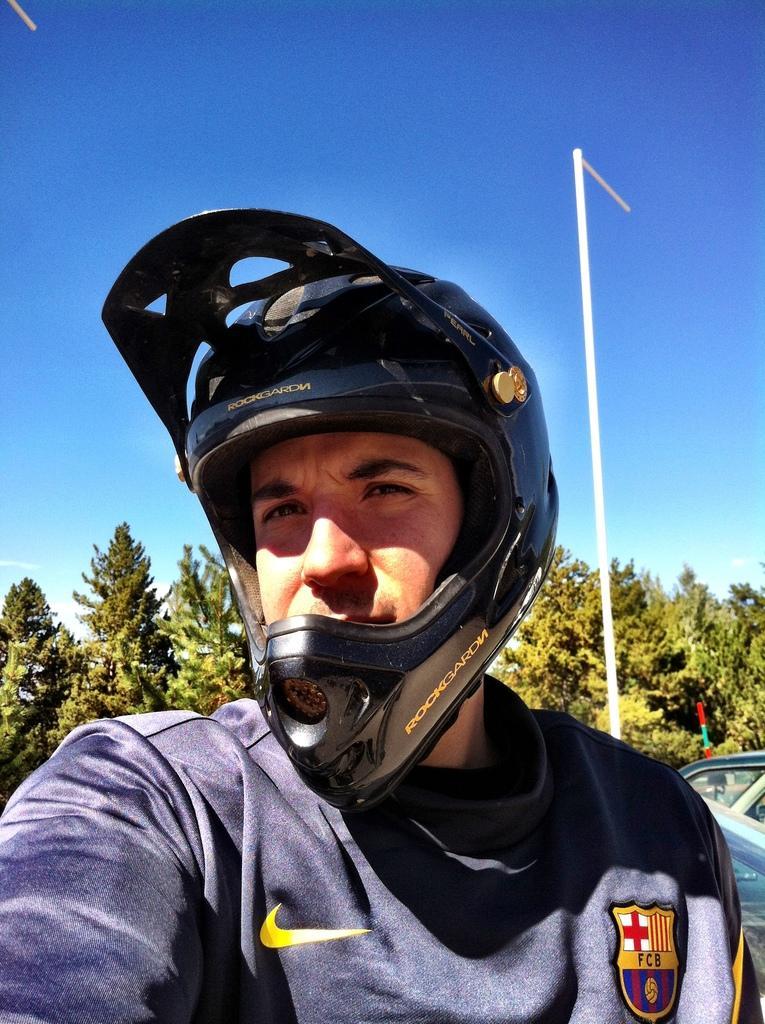How would you summarize this image in a sentence or two? In this image we can see a person wearing a helmet, behind him we can see a pole, vehicle and some trees, in the background we can see the sky, 